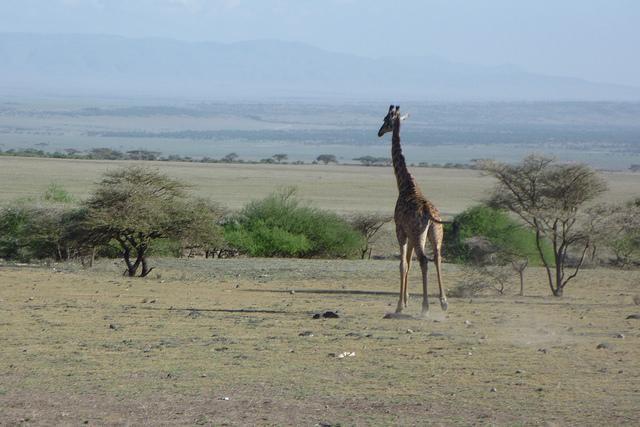How many giraffes are in the picture?
Give a very brief answer. 1. 